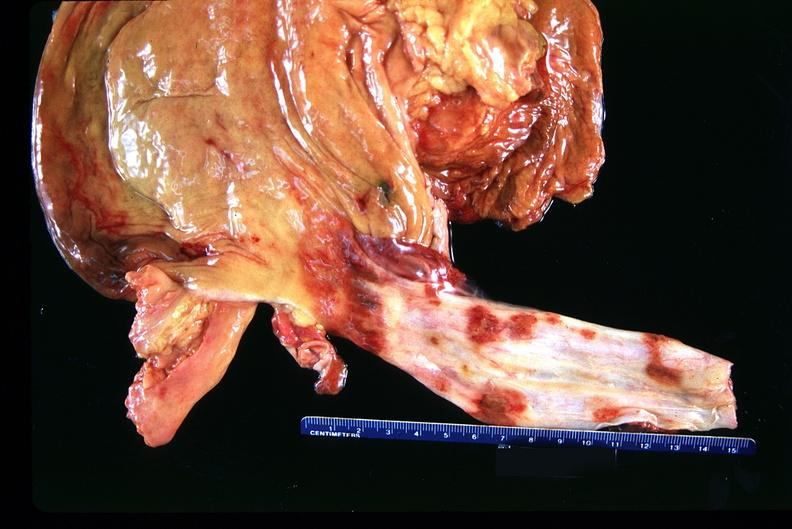what is present?
Answer the question using a single word or phrase. Gastrointestinal 